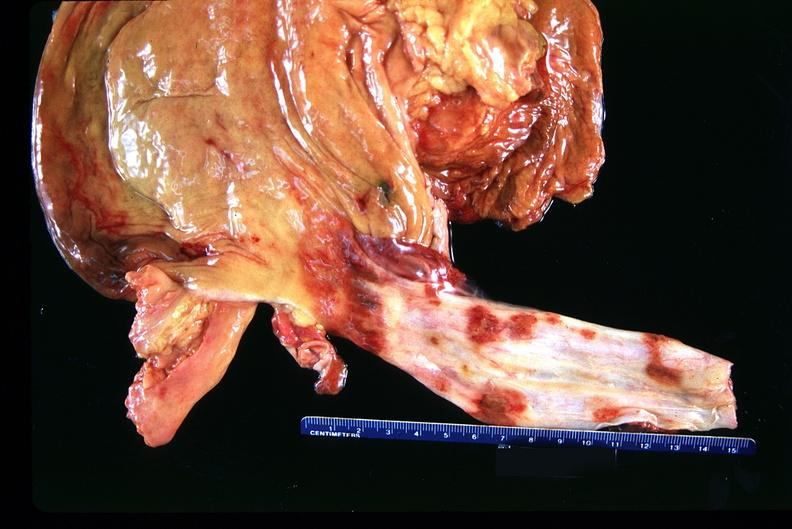what is present?
Answer the question using a single word or phrase. Gastrointestinal 